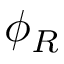Convert formula to latex. <formula><loc_0><loc_0><loc_500><loc_500>\phi _ { R }</formula> 